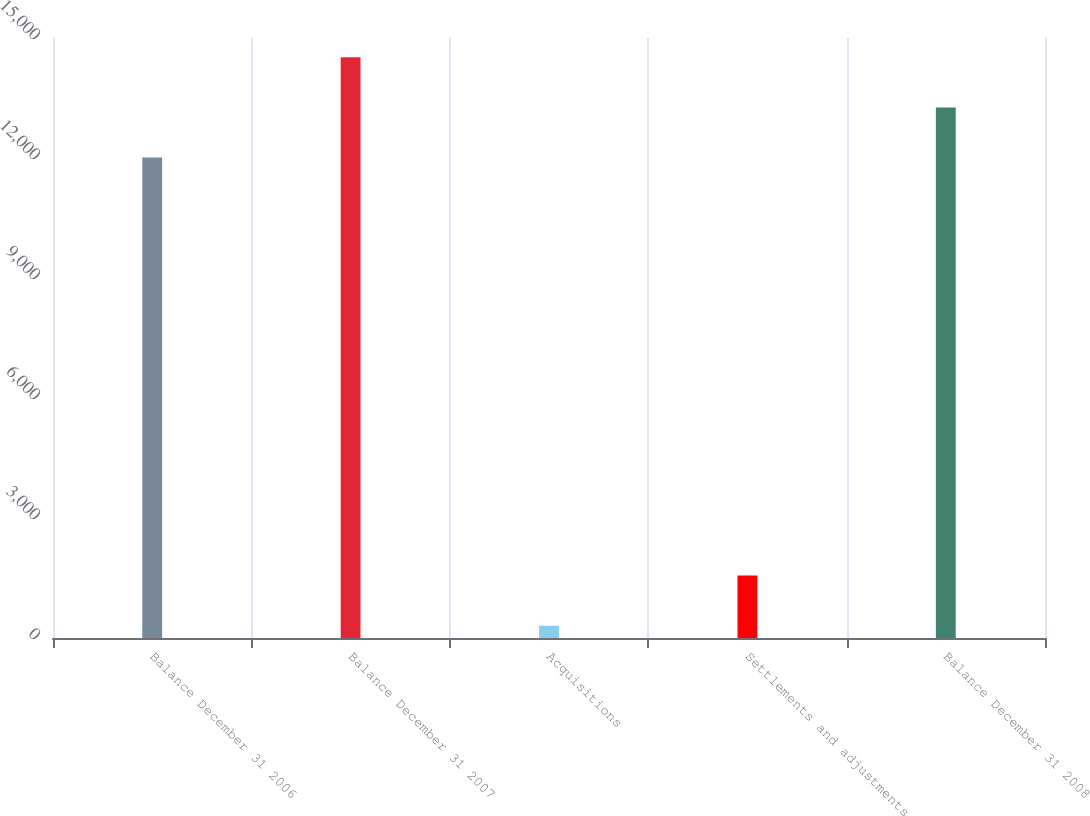Convert chart. <chart><loc_0><loc_0><loc_500><loc_500><bar_chart><fcel>Balance December 31 2006<fcel>Balance December 31 2007<fcel>Acquisitions<fcel>Settlements and adjustments<fcel>Balance December 31 2008<nl><fcel>12010<fcel>14517.2<fcel>306<fcel>1559.6<fcel>13263.6<nl></chart> 